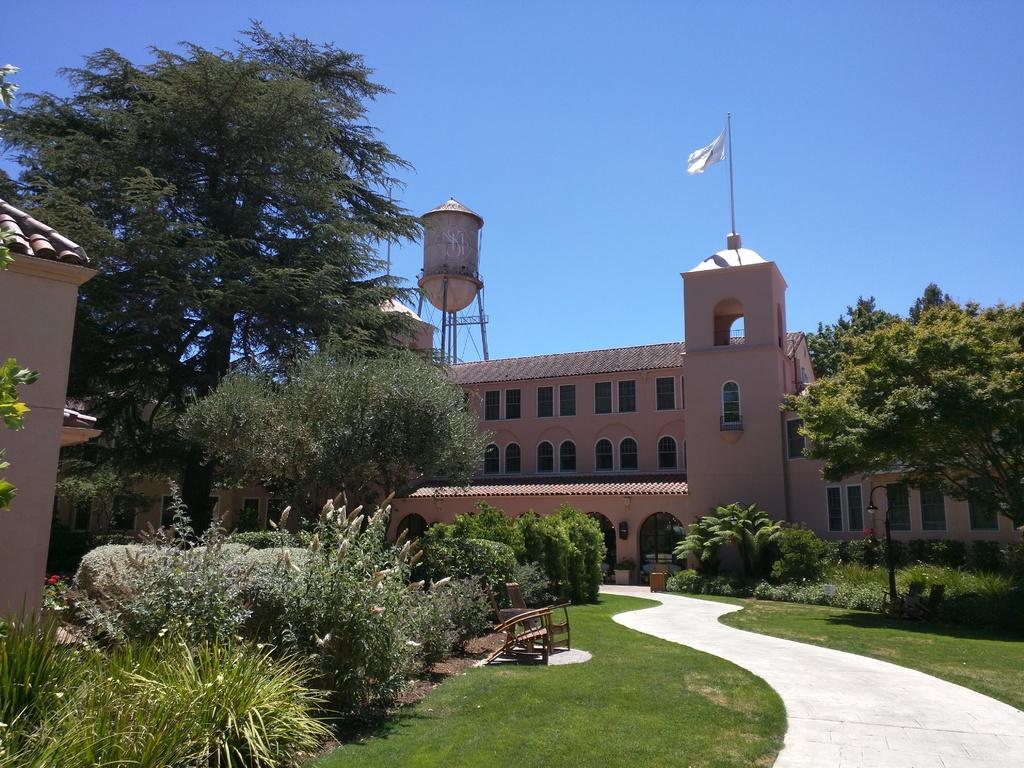In one or two sentences, can you explain what this image depicts? In this image we can see trees, plants, chairs and building. Background of the image, one tank is there. One flag is attached to the top of the building. At the top of the image, the blue color sky is present. At the bottom of the image, grassy land is there. 